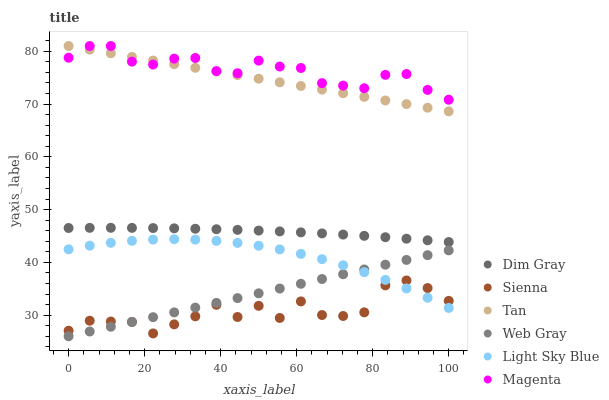Does Sienna have the minimum area under the curve?
Answer yes or no. Yes. Does Magenta have the maximum area under the curve?
Answer yes or no. Yes. Does Web Gray have the minimum area under the curve?
Answer yes or no. No. Does Web Gray have the maximum area under the curve?
Answer yes or no. No. Is Tan the smoothest?
Answer yes or no. Yes. Is Sienna the roughest?
Answer yes or no. Yes. Is Web Gray the smoothest?
Answer yes or no. No. Is Web Gray the roughest?
Answer yes or no. No. Does Web Gray have the lowest value?
Answer yes or no. Yes. Does Sienna have the lowest value?
Answer yes or no. No. Does Magenta have the highest value?
Answer yes or no. Yes. Does Web Gray have the highest value?
Answer yes or no. No. Is Web Gray less than Magenta?
Answer yes or no. Yes. Is Magenta greater than Sienna?
Answer yes or no. Yes. Does Magenta intersect Tan?
Answer yes or no. Yes. Is Magenta less than Tan?
Answer yes or no. No. Is Magenta greater than Tan?
Answer yes or no. No. Does Web Gray intersect Magenta?
Answer yes or no. No. 